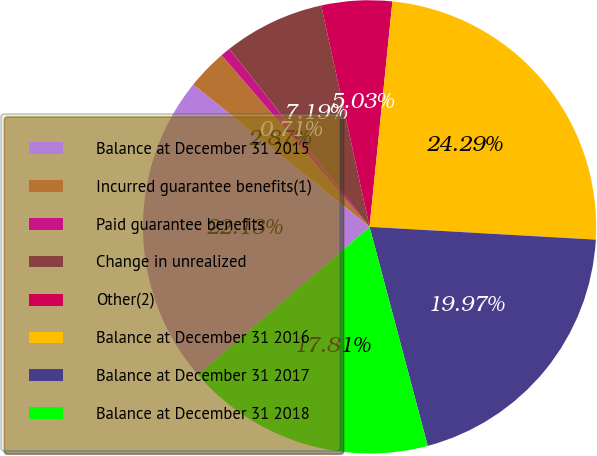<chart> <loc_0><loc_0><loc_500><loc_500><pie_chart><fcel>Balance at December 31 2015<fcel>Incurred guarantee benefits(1)<fcel>Paid guarantee benefits<fcel>Change in unrealized<fcel>Other(2)<fcel>Balance at December 31 2016<fcel>Balance at December 31 2017<fcel>Balance at December 31 2018<nl><fcel>22.13%<fcel>2.87%<fcel>0.71%<fcel>7.19%<fcel>5.03%<fcel>24.29%<fcel>19.97%<fcel>17.81%<nl></chart> 